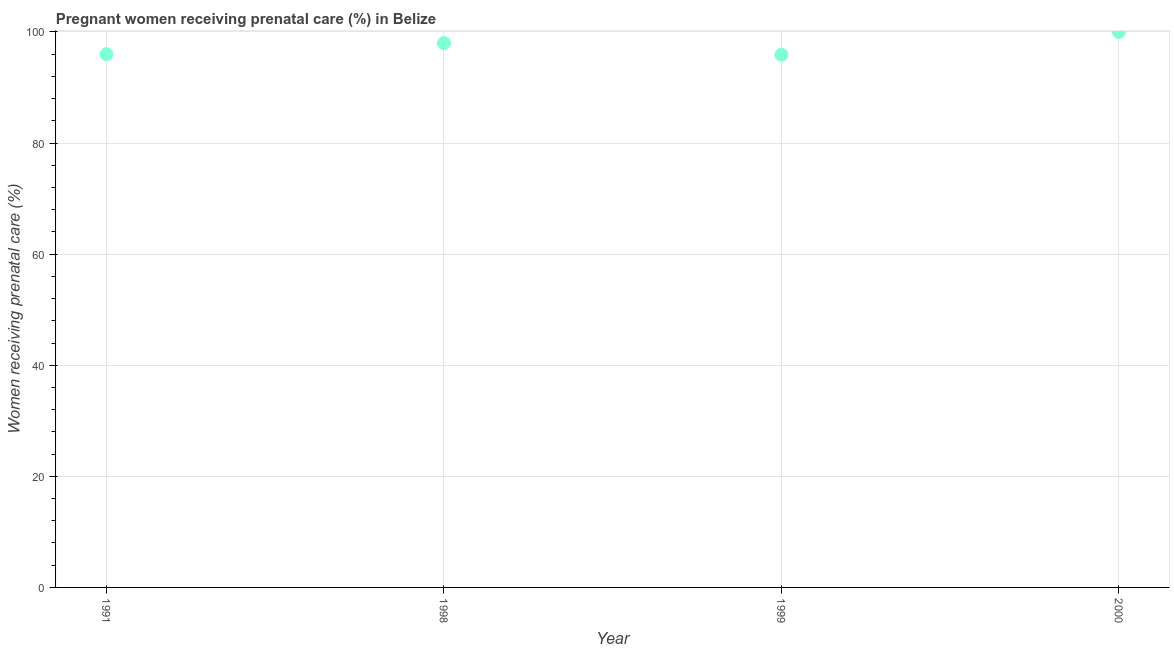What is the percentage of pregnant women receiving prenatal care in 1991?
Your response must be concise. 96. Across all years, what is the minimum percentage of pregnant women receiving prenatal care?
Make the answer very short. 95.9. In which year was the percentage of pregnant women receiving prenatal care maximum?
Your answer should be compact. 2000. In which year was the percentage of pregnant women receiving prenatal care minimum?
Offer a terse response. 1999. What is the sum of the percentage of pregnant women receiving prenatal care?
Ensure brevity in your answer.  389.9. What is the average percentage of pregnant women receiving prenatal care per year?
Provide a succinct answer. 97.47. What is the median percentage of pregnant women receiving prenatal care?
Keep it short and to the point. 97. Do a majority of the years between 1991 and 1999 (inclusive) have percentage of pregnant women receiving prenatal care greater than 36 %?
Make the answer very short. Yes. What is the ratio of the percentage of pregnant women receiving prenatal care in 1999 to that in 2000?
Your response must be concise. 0.96. What is the difference between the highest and the second highest percentage of pregnant women receiving prenatal care?
Offer a terse response. 2. What is the difference between the highest and the lowest percentage of pregnant women receiving prenatal care?
Ensure brevity in your answer.  4.1. In how many years, is the percentage of pregnant women receiving prenatal care greater than the average percentage of pregnant women receiving prenatal care taken over all years?
Provide a succinct answer. 2. Does the percentage of pregnant women receiving prenatal care monotonically increase over the years?
Offer a terse response. No. How many years are there in the graph?
Make the answer very short. 4. Does the graph contain any zero values?
Your response must be concise. No. What is the title of the graph?
Offer a terse response. Pregnant women receiving prenatal care (%) in Belize. What is the label or title of the X-axis?
Give a very brief answer. Year. What is the label or title of the Y-axis?
Your answer should be very brief. Women receiving prenatal care (%). What is the Women receiving prenatal care (%) in 1991?
Make the answer very short. 96. What is the Women receiving prenatal care (%) in 1999?
Offer a terse response. 95.9. What is the difference between the Women receiving prenatal care (%) in 1991 and 1998?
Provide a succinct answer. -2. What is the difference between the Women receiving prenatal care (%) in 1991 and 1999?
Your response must be concise. 0.1. What is the difference between the Women receiving prenatal care (%) in 1998 and 1999?
Offer a very short reply. 2.1. What is the difference between the Women receiving prenatal care (%) in 1998 and 2000?
Ensure brevity in your answer.  -2. What is the ratio of the Women receiving prenatal care (%) in 1991 to that in 1998?
Provide a short and direct response. 0.98. What is the ratio of the Women receiving prenatal care (%) in 1991 to that in 2000?
Offer a terse response. 0.96. What is the ratio of the Women receiving prenatal care (%) in 1999 to that in 2000?
Provide a succinct answer. 0.96. 